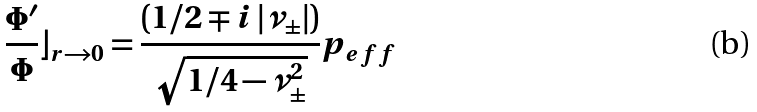<formula> <loc_0><loc_0><loc_500><loc_500>\frac { \Phi ^ { \prime } } { \Phi } \rfloor _ { r \rightarrow 0 } = \frac { ( 1 / 2 \mp i \left | \nu _ { \pm } \right | ) } { \sqrt { 1 / 4 - \nu _ { \pm } ^ { 2 } } } p _ { e f f }</formula> 